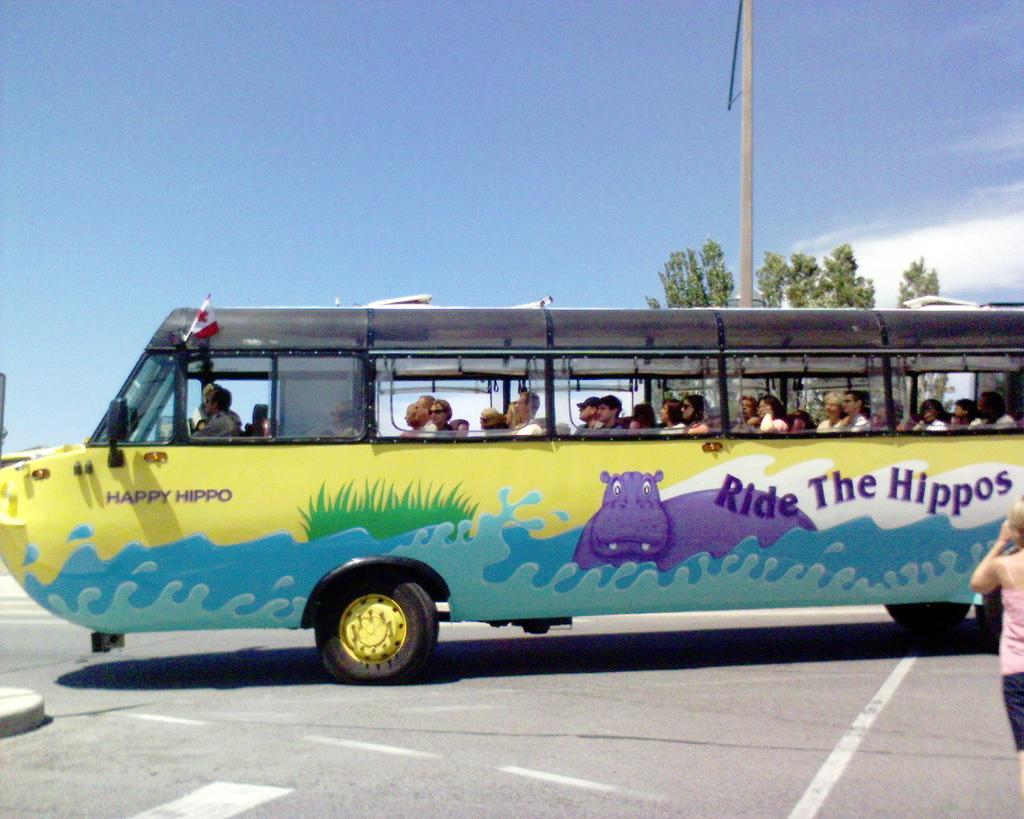<image>
Render a clear and concise summary of the photo. Bus going to Ride The Hippos full of people. 